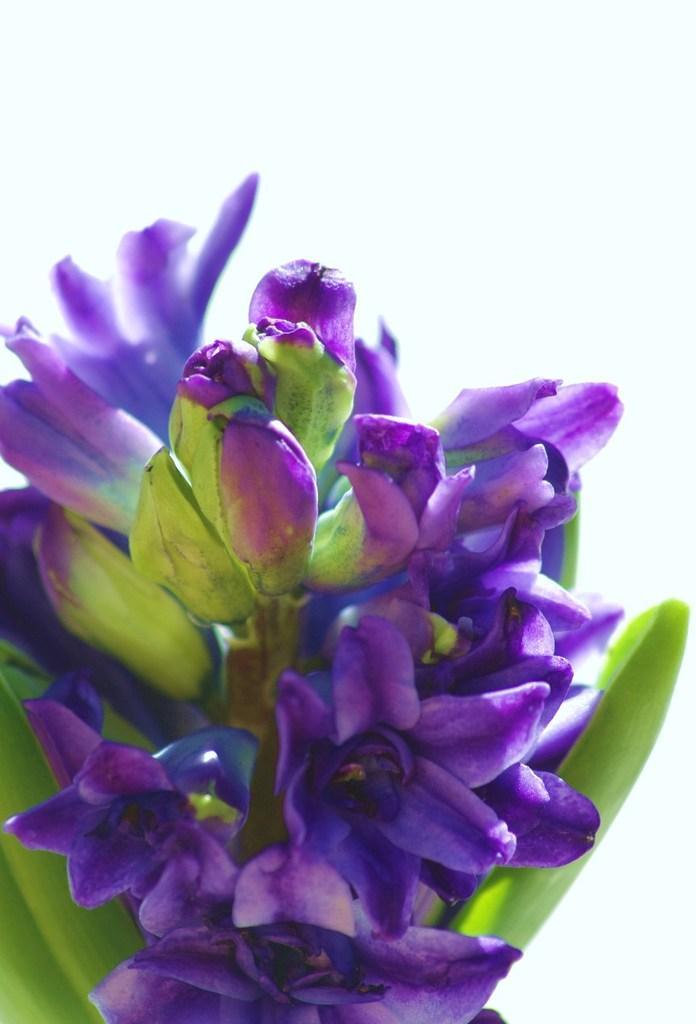Please provide a concise description of this image. In the image there are purple flowers to a plant and above its sky. 